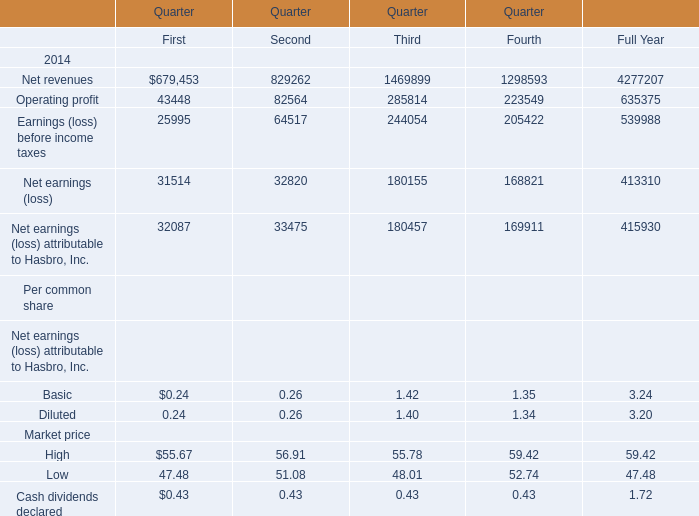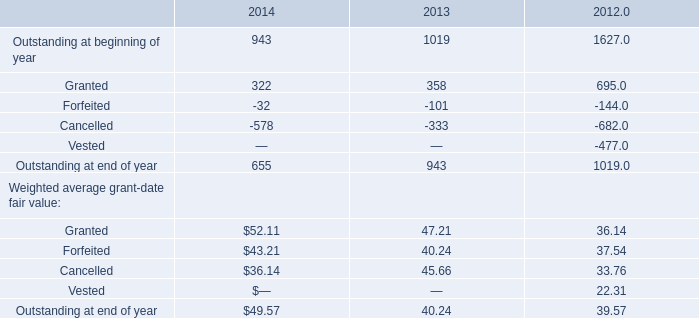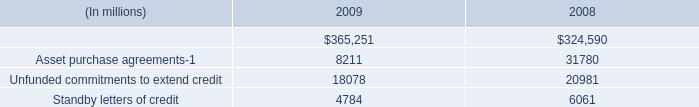what is the percentage change in the indemnified securities financing from 2008 to 2009? 
Computations: ((365251 - 324590) / 324590)
Answer: 0.12527. 